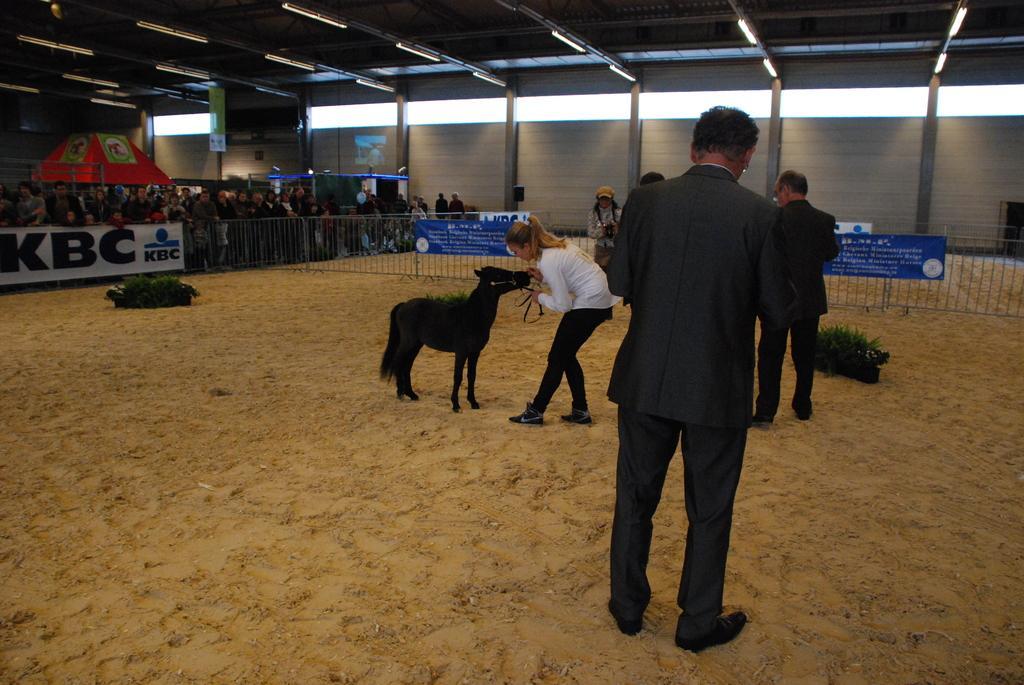Please provide a concise description of this image. In the image we can see there are many people standing, wearing clothes and some of them are wearing shoes. We can even see an animal, black in color. Here we can see the plant pots, sand and the fence. Here we can see the poster and text on the poster. Here we can see the lights and the windows. 